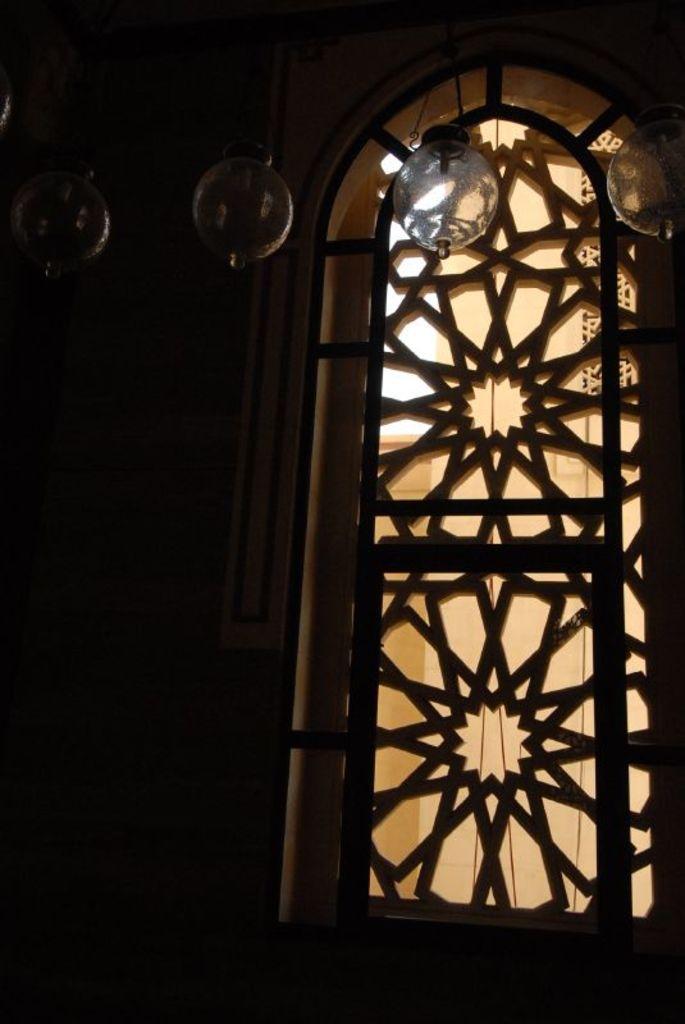Can you describe this image briefly? In this image, I can see a window with a design. At the top of the image, there are glass lanterns hanging. 